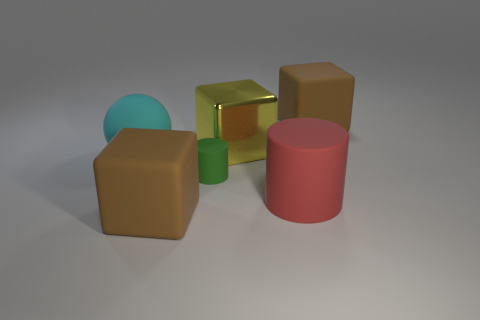Is the number of red rubber things that are in front of the green thing greater than the number of tiny red metallic balls?
Ensure brevity in your answer.  Yes. There is a thing that is to the left of the tiny green rubber object and in front of the ball; what size is it?
Provide a succinct answer. Large. What is the material of the small thing that is the same shape as the big red thing?
Your response must be concise. Rubber. There is a brown thing left of the red cylinder; is its size the same as the big matte cylinder?
Provide a short and direct response. Yes. The big thing that is behind the big red object and on the left side of the big metallic object is what color?
Make the answer very short. Cyan. What number of brown matte things are on the right side of the brown matte object on the left side of the big yellow thing?
Your response must be concise. 1. Is the shape of the green object the same as the large red rubber object?
Your answer should be compact. Yes. Do the tiny rubber object and the big red rubber thing on the right side of the metal block have the same shape?
Offer a terse response. Yes. What is the color of the big matte block that is left of the big red matte cylinder that is on the left side of the big rubber block that is behind the red matte cylinder?
Keep it short and to the point. Brown. Is there anything else that is made of the same material as the yellow cube?
Offer a very short reply. No. 